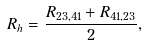Convert formula to latex. <formula><loc_0><loc_0><loc_500><loc_500>R _ { h } = \frac { R _ { 2 3 , 4 1 } + R _ { 4 1 , 2 3 } } { 2 } ,</formula> 